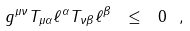Convert formula to latex. <formula><loc_0><loc_0><loc_500><loc_500>g ^ { \mu \nu } T _ { \mu \alpha } \ell ^ { \alpha } T _ { \nu \beta } \ell ^ { \beta } \ \leq \ 0 \ ,</formula> 